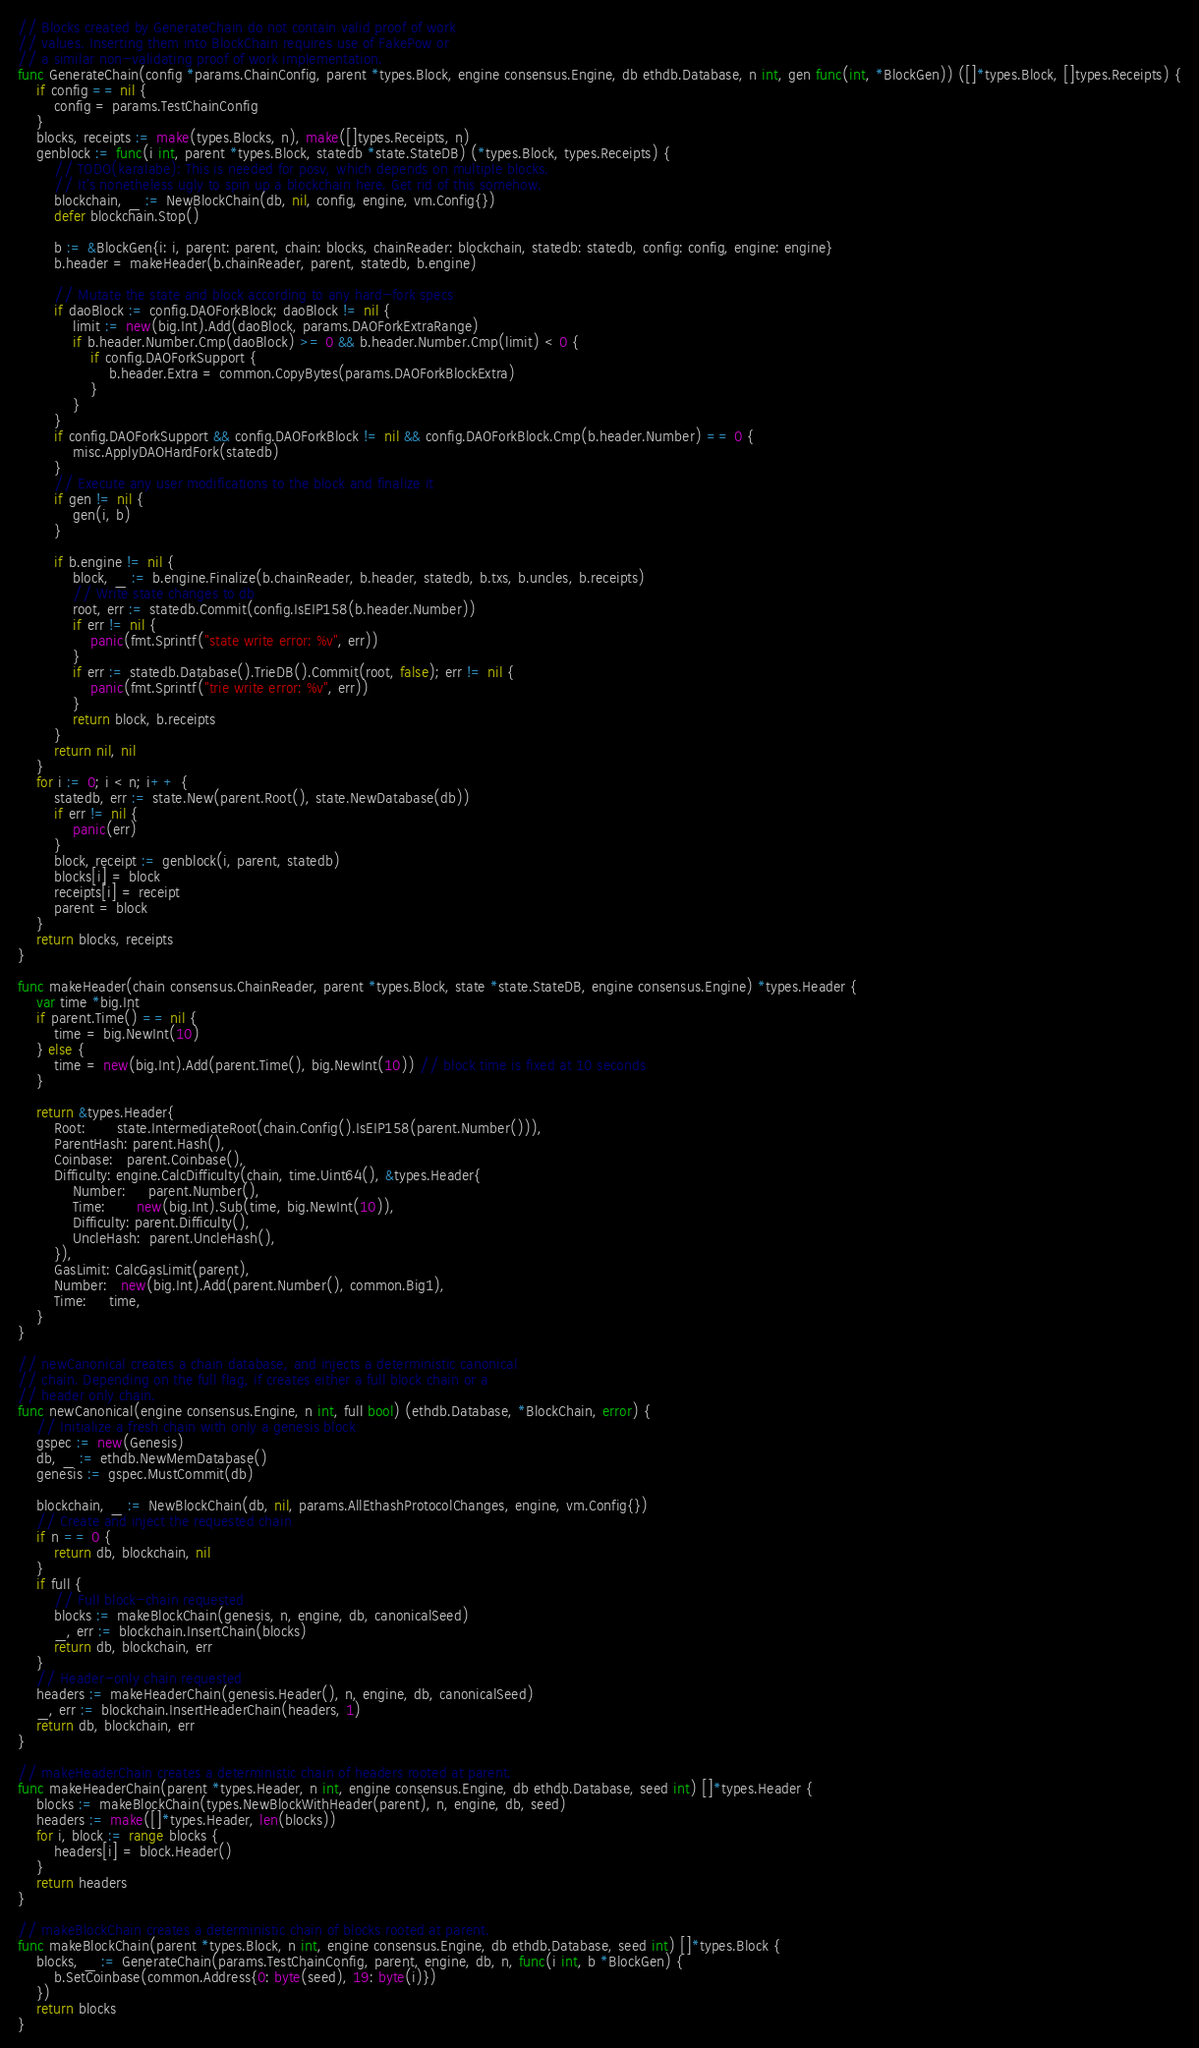Convert code to text. <code><loc_0><loc_0><loc_500><loc_500><_Go_>// Blocks created by GenerateChain do not contain valid proof of work
// values. Inserting them into BlockChain requires use of FakePow or
// a similar non-validating proof of work implementation.
func GenerateChain(config *params.ChainConfig, parent *types.Block, engine consensus.Engine, db ethdb.Database, n int, gen func(int, *BlockGen)) ([]*types.Block, []types.Receipts) {
	if config == nil {
		config = params.TestChainConfig
	}
	blocks, receipts := make(types.Blocks, n), make([]types.Receipts, n)
	genblock := func(i int, parent *types.Block, statedb *state.StateDB) (*types.Block, types.Receipts) {
		// TODO(karalabe): This is needed for posv, which depends on multiple blocks.
		// It's nonetheless ugly to spin up a blockchain here. Get rid of this somehow.
		blockchain, _ := NewBlockChain(db, nil, config, engine, vm.Config{})
		defer blockchain.Stop()

		b := &BlockGen{i: i, parent: parent, chain: blocks, chainReader: blockchain, statedb: statedb, config: config, engine: engine}
		b.header = makeHeader(b.chainReader, parent, statedb, b.engine)

		// Mutate the state and block according to any hard-fork specs
		if daoBlock := config.DAOForkBlock; daoBlock != nil {
			limit := new(big.Int).Add(daoBlock, params.DAOForkExtraRange)
			if b.header.Number.Cmp(daoBlock) >= 0 && b.header.Number.Cmp(limit) < 0 {
				if config.DAOForkSupport {
					b.header.Extra = common.CopyBytes(params.DAOForkBlockExtra)
				}
			}
		}
		if config.DAOForkSupport && config.DAOForkBlock != nil && config.DAOForkBlock.Cmp(b.header.Number) == 0 {
			misc.ApplyDAOHardFork(statedb)
		}
		// Execute any user modifications to the block and finalize it
		if gen != nil {
			gen(i, b)
		}

		if b.engine != nil {
			block, _ := b.engine.Finalize(b.chainReader, b.header, statedb, b.txs, b.uncles, b.receipts)
			// Write state changes to db
			root, err := statedb.Commit(config.IsEIP158(b.header.Number))
			if err != nil {
				panic(fmt.Sprintf("state write error: %v", err))
			}
			if err := statedb.Database().TrieDB().Commit(root, false); err != nil {
				panic(fmt.Sprintf("trie write error: %v", err))
			}
			return block, b.receipts
		}
		return nil, nil
	}
	for i := 0; i < n; i++ {
		statedb, err := state.New(parent.Root(), state.NewDatabase(db))
		if err != nil {
			panic(err)
		}
		block, receipt := genblock(i, parent, statedb)
		blocks[i] = block
		receipts[i] = receipt
		parent = block
	}
	return blocks, receipts
}

func makeHeader(chain consensus.ChainReader, parent *types.Block, state *state.StateDB, engine consensus.Engine) *types.Header {
	var time *big.Int
	if parent.Time() == nil {
		time = big.NewInt(10)
	} else {
		time = new(big.Int).Add(parent.Time(), big.NewInt(10)) // block time is fixed at 10 seconds
	}

	return &types.Header{
		Root:       state.IntermediateRoot(chain.Config().IsEIP158(parent.Number())),
		ParentHash: parent.Hash(),
		Coinbase:   parent.Coinbase(),
		Difficulty: engine.CalcDifficulty(chain, time.Uint64(), &types.Header{
			Number:     parent.Number(),
			Time:       new(big.Int).Sub(time, big.NewInt(10)),
			Difficulty: parent.Difficulty(),
			UncleHash:  parent.UncleHash(),
		}),
		GasLimit: CalcGasLimit(parent),
		Number:   new(big.Int).Add(parent.Number(), common.Big1),
		Time:     time,
	}
}

// newCanonical creates a chain database, and injects a deterministic canonical
// chain. Depending on the full flag, if creates either a full block chain or a
// header only chain.
func newCanonical(engine consensus.Engine, n int, full bool) (ethdb.Database, *BlockChain, error) {
	// Initialize a fresh chain with only a genesis block
	gspec := new(Genesis)
	db, _ := ethdb.NewMemDatabase()
	genesis := gspec.MustCommit(db)

	blockchain, _ := NewBlockChain(db, nil, params.AllEthashProtocolChanges, engine, vm.Config{})
	// Create and inject the requested chain
	if n == 0 {
		return db, blockchain, nil
	}
	if full {
		// Full block-chain requested
		blocks := makeBlockChain(genesis, n, engine, db, canonicalSeed)
		_, err := blockchain.InsertChain(blocks)
		return db, blockchain, err
	}
	// Header-only chain requested
	headers := makeHeaderChain(genesis.Header(), n, engine, db, canonicalSeed)
	_, err := blockchain.InsertHeaderChain(headers, 1)
	return db, blockchain, err
}

// makeHeaderChain creates a deterministic chain of headers rooted at parent.
func makeHeaderChain(parent *types.Header, n int, engine consensus.Engine, db ethdb.Database, seed int) []*types.Header {
	blocks := makeBlockChain(types.NewBlockWithHeader(parent), n, engine, db, seed)
	headers := make([]*types.Header, len(blocks))
	for i, block := range blocks {
		headers[i] = block.Header()
	}
	return headers
}

// makeBlockChain creates a deterministic chain of blocks rooted at parent.
func makeBlockChain(parent *types.Block, n int, engine consensus.Engine, db ethdb.Database, seed int) []*types.Block {
	blocks, _ := GenerateChain(params.TestChainConfig, parent, engine, db, n, func(i int, b *BlockGen) {
		b.SetCoinbase(common.Address{0: byte(seed), 19: byte(i)})
	})
	return blocks
}
</code> 